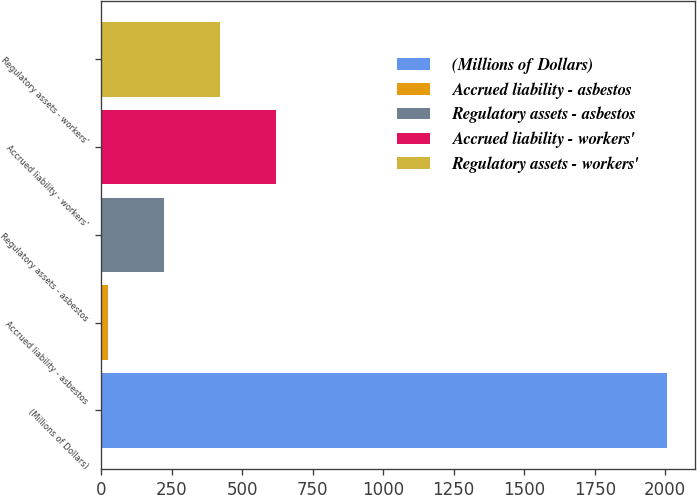Convert chart to OTSL. <chart><loc_0><loc_0><loc_500><loc_500><bar_chart><fcel>(Millions of Dollars)<fcel>Accrued liability - asbestos<fcel>Regulatory assets - asbestos<fcel>Accrued liability - workers'<fcel>Regulatory assets - workers'<nl><fcel>2005<fcel>25<fcel>223<fcel>619<fcel>421<nl></chart> 